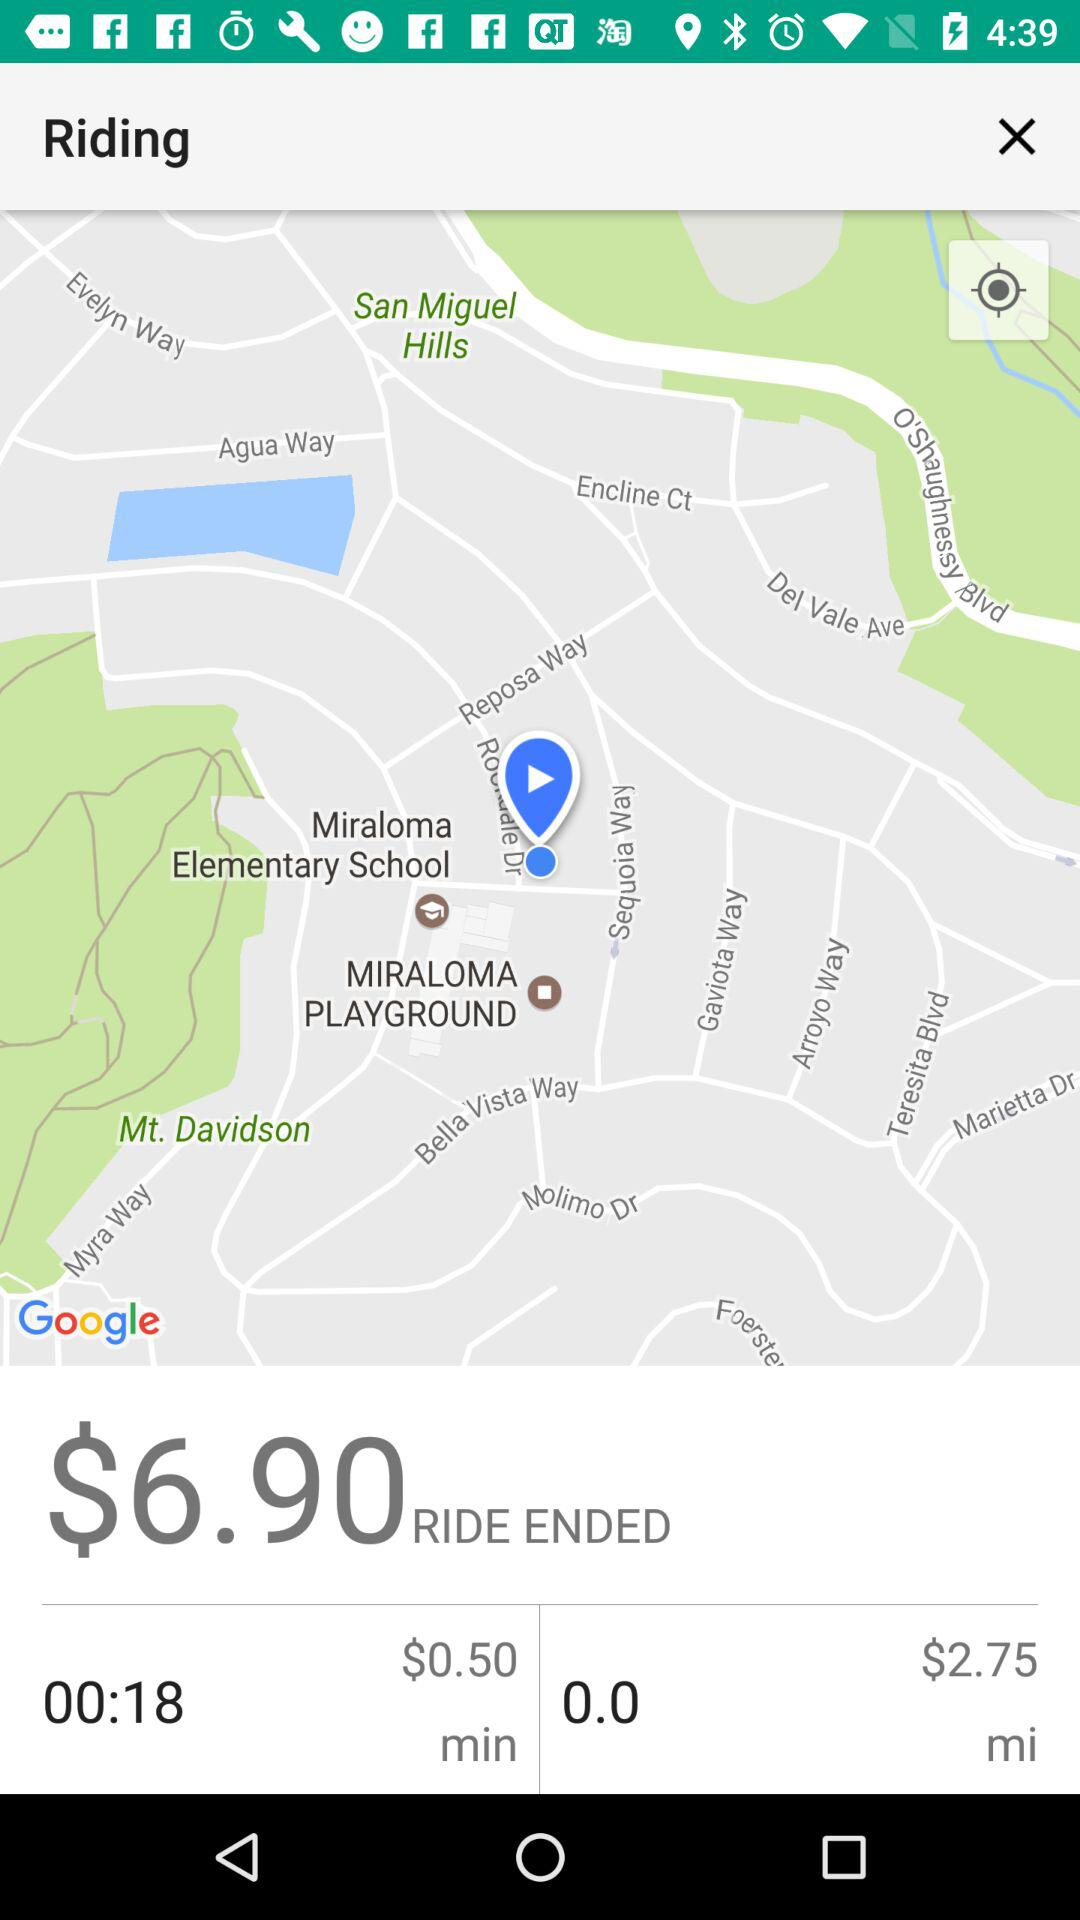How long was the ride in minutes?
Answer the question using a single word or phrase. 18 